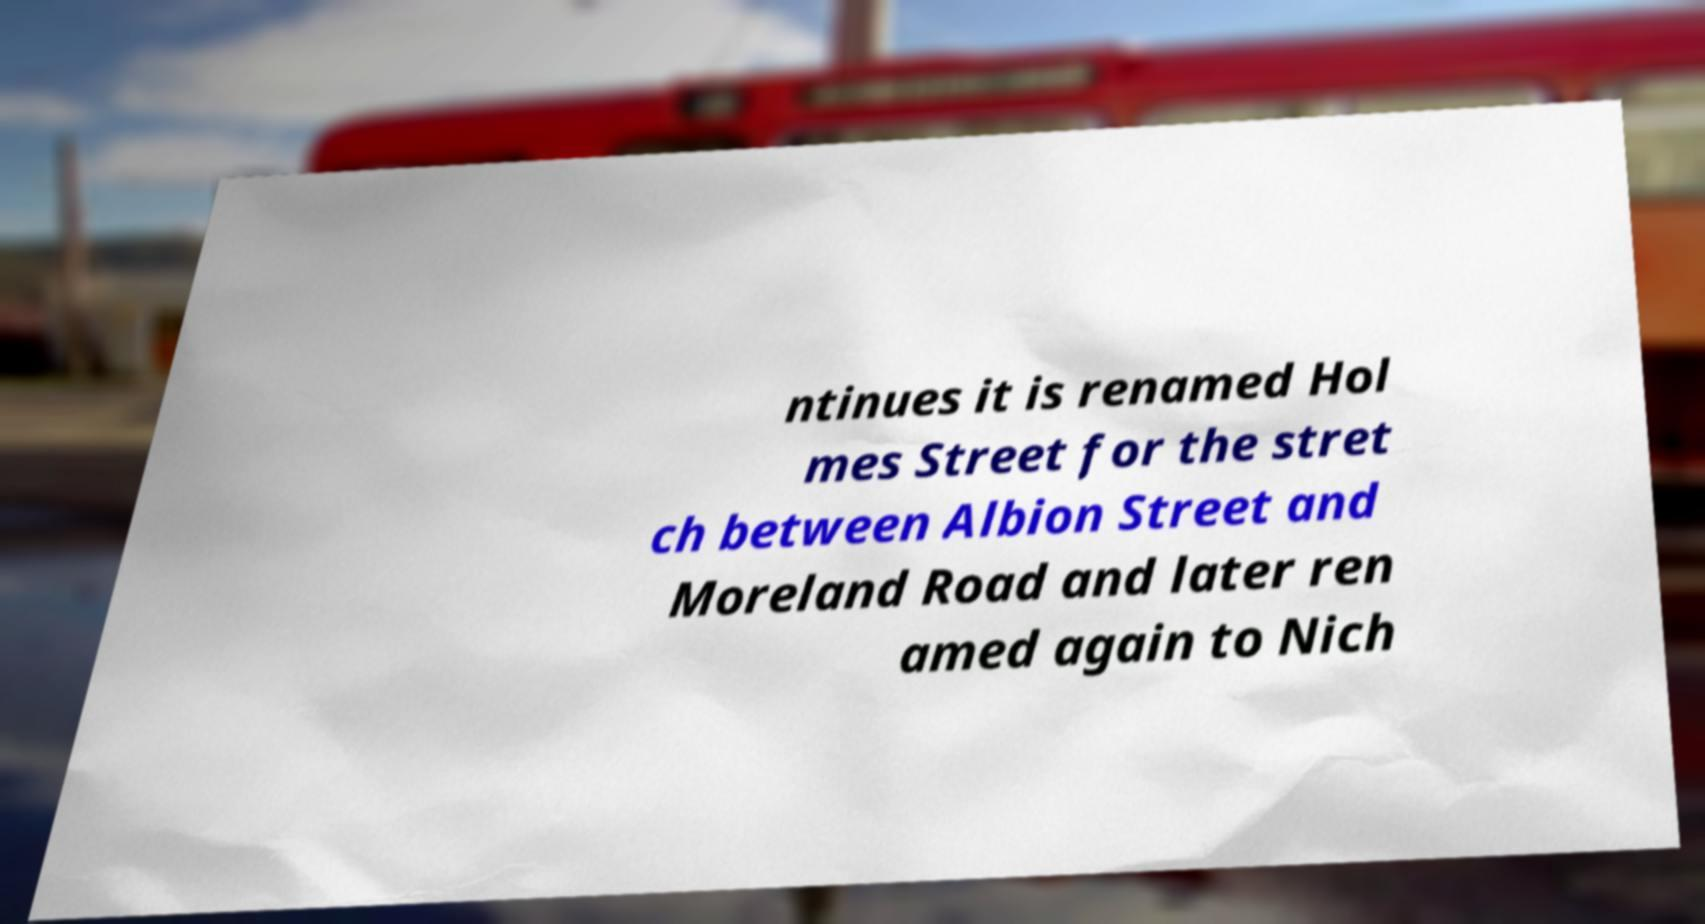Can you accurately transcribe the text from the provided image for me? ntinues it is renamed Hol mes Street for the stret ch between Albion Street and Moreland Road and later ren amed again to Nich 